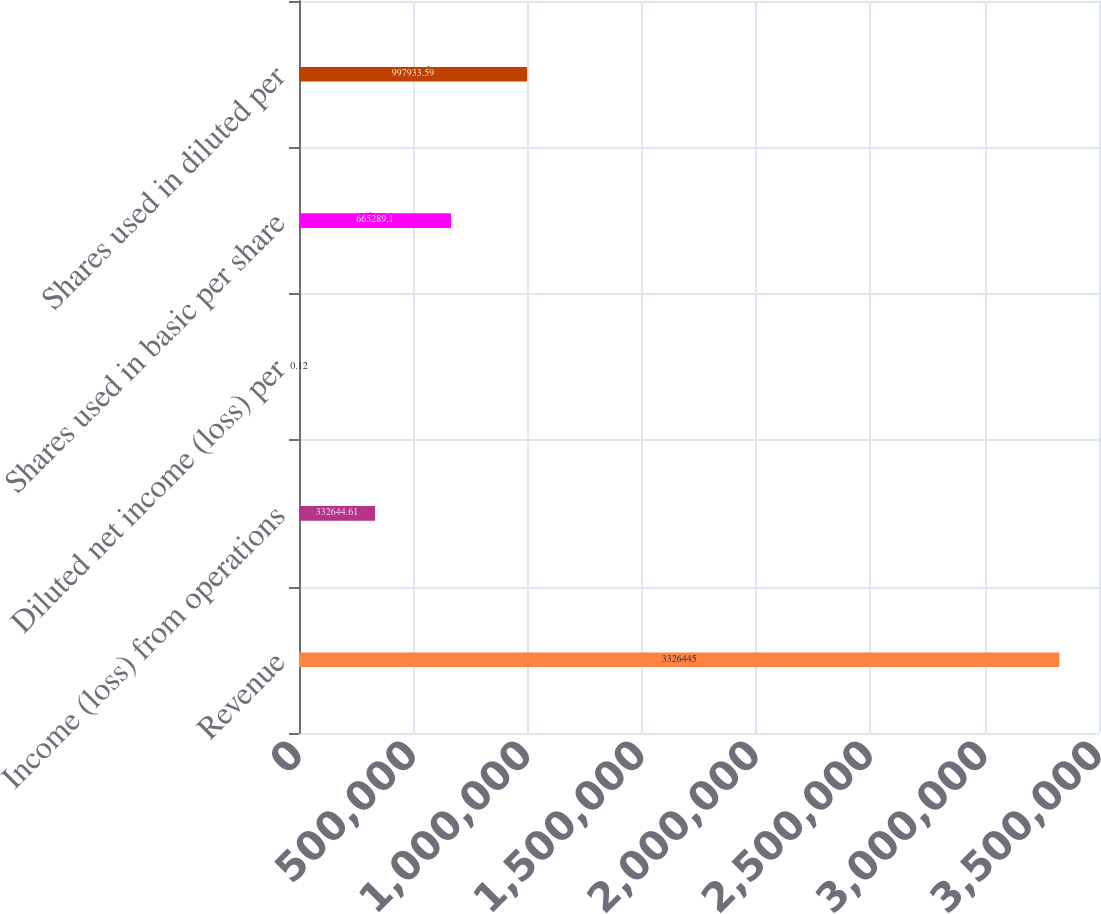<chart> <loc_0><loc_0><loc_500><loc_500><bar_chart><fcel>Revenue<fcel>Income (loss) from operations<fcel>Diluted net income (loss) per<fcel>Shares used in basic per share<fcel>Shares used in diluted per<nl><fcel>3.32644e+06<fcel>332645<fcel>0.12<fcel>665289<fcel>997934<nl></chart> 